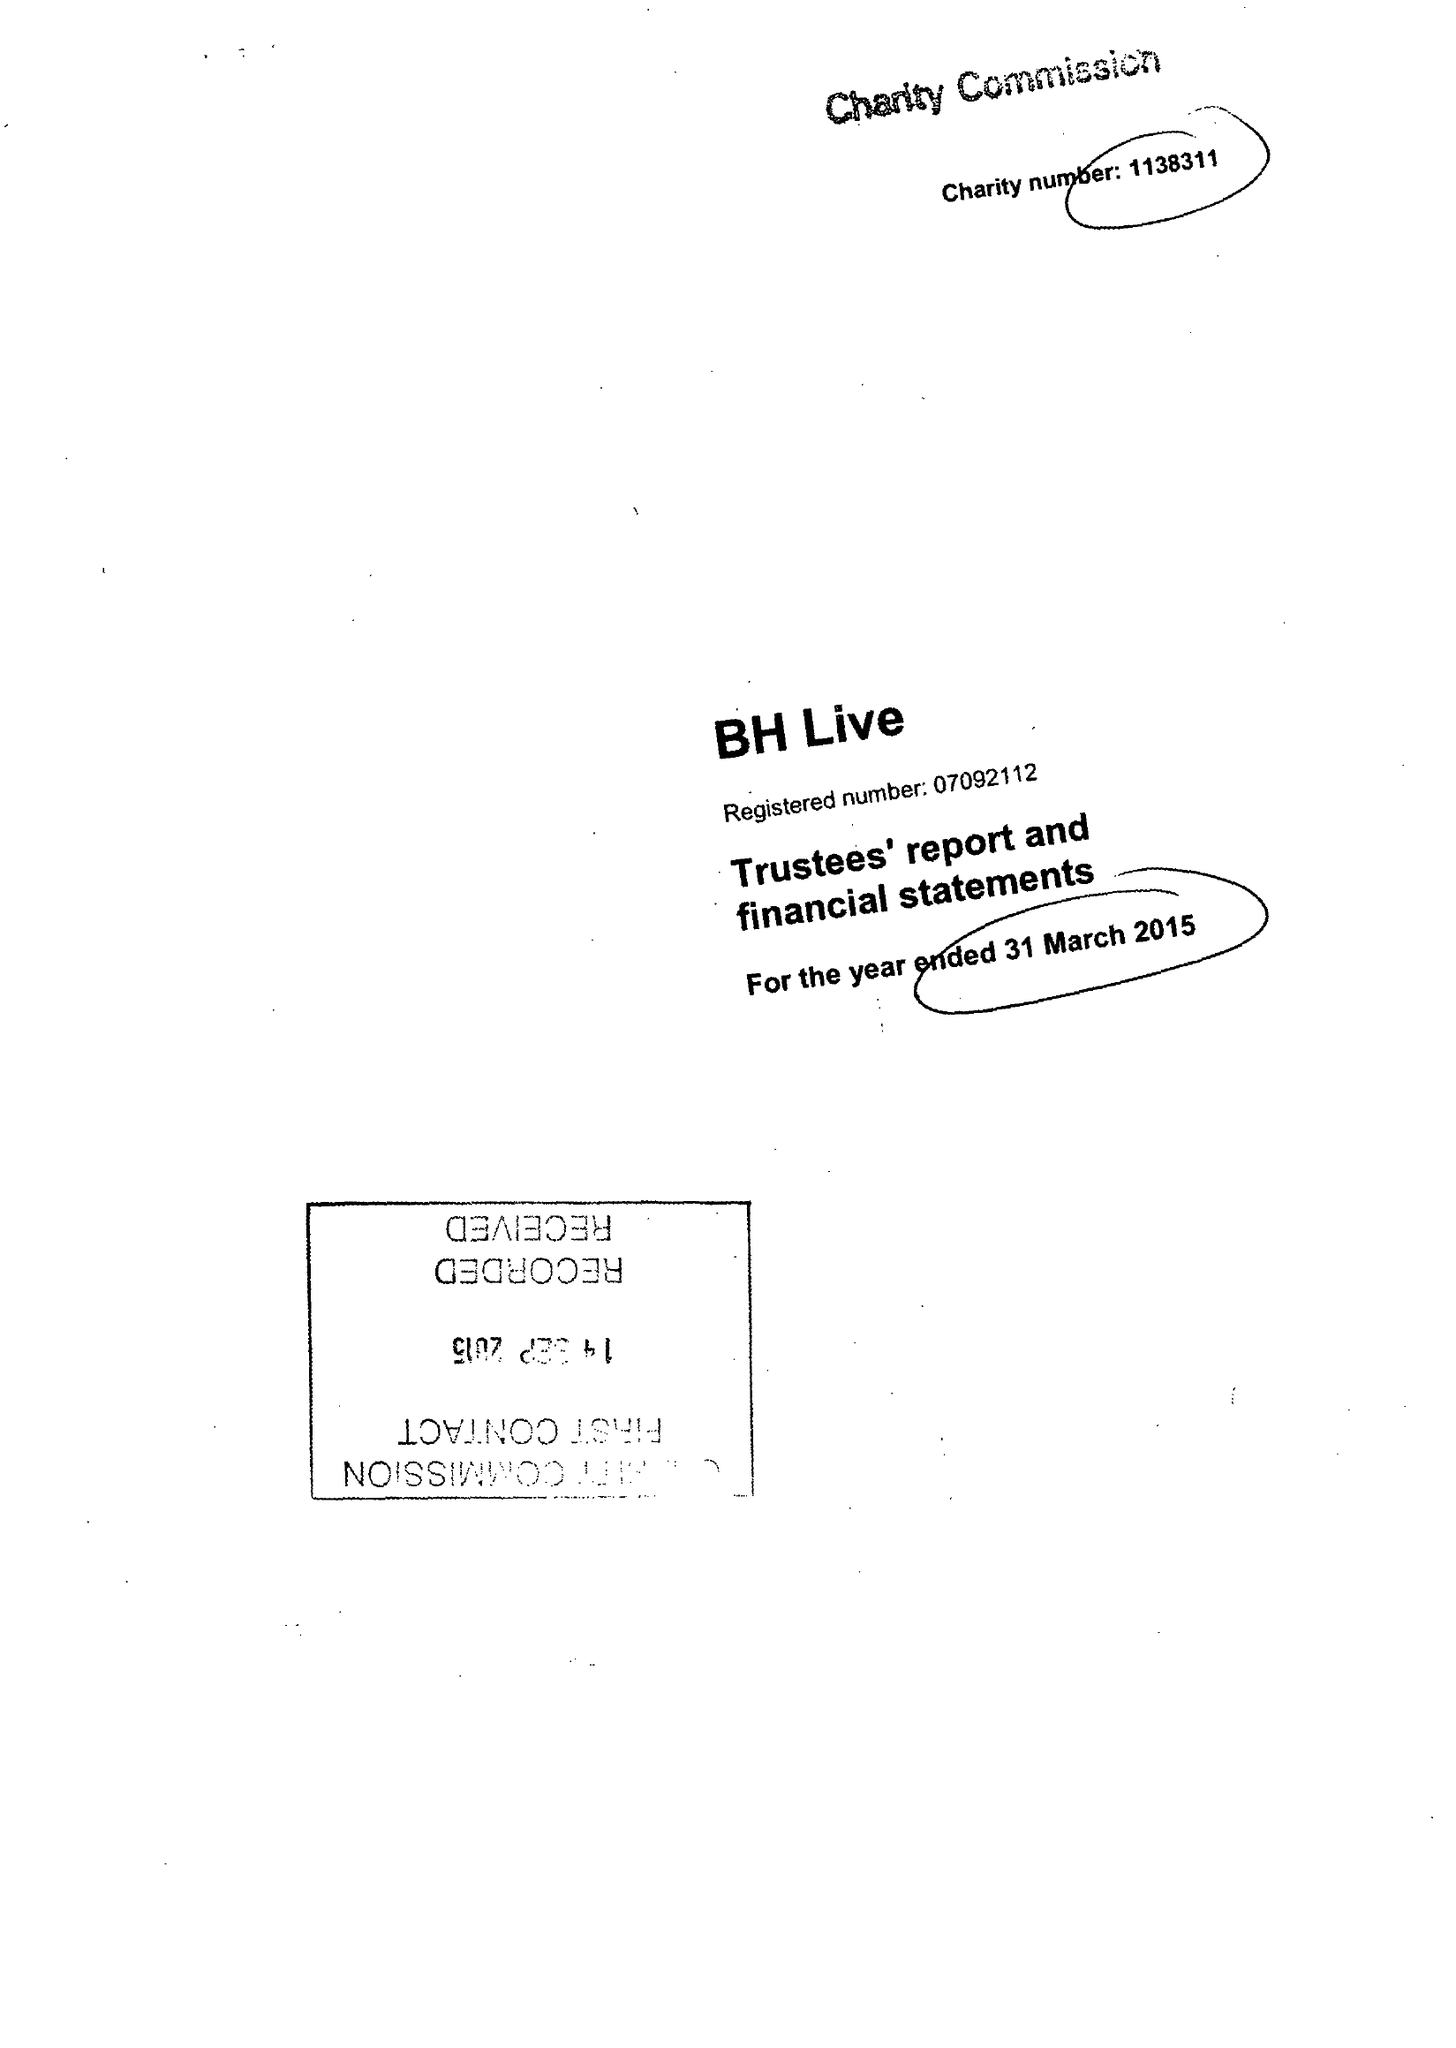What is the value for the spending_annually_in_british_pounds?
Answer the question using a single word or phrase. 23100720.00 